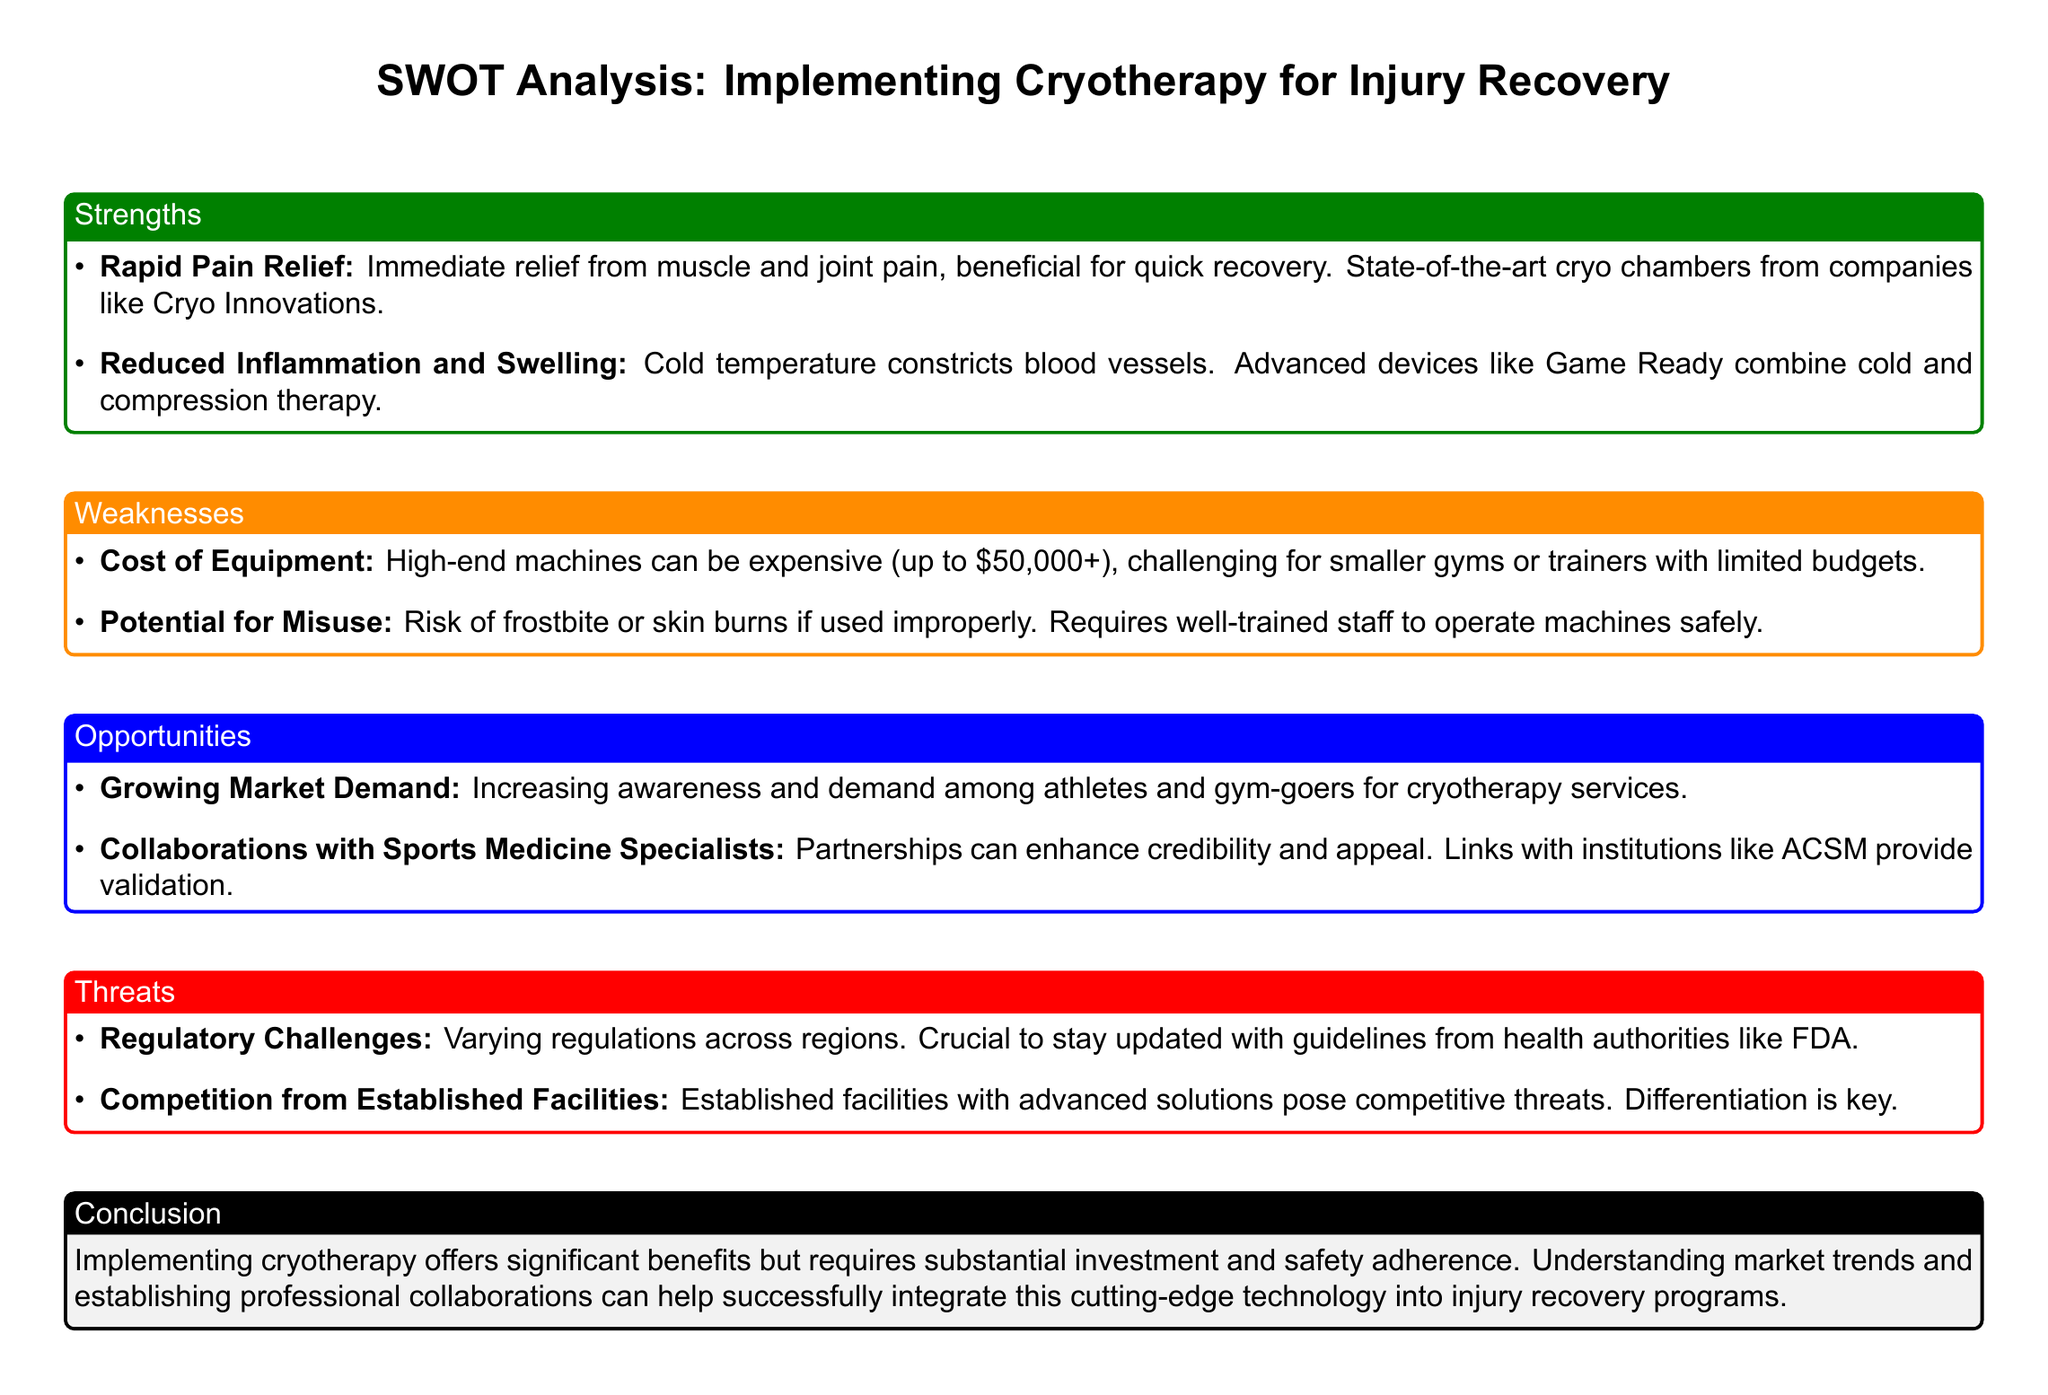What is one strength of implementing cryotherapy? The strength is described in the strengths section, which mentions rapid pain relief as an immediate benefit of cryotherapy.
Answer: Rapid Pain Relief What is the cost of cryotherapy equipment? The document states that high-end machines can cost up to $50,000 or more, which is mentioned in the weaknesses section.
Answer: $50,000+ What is a significant opportunity for cryotherapy services? The growing market demand and increasing awareness among athletes and gym-goers is highlighted as an opportunity in the document.
Answer: Growing Market Demand What is a potential threat to implementing cryotherapy? Regulatory challenges are mentioned as a threat, indicating there are varying regulations across regions.
Answer: Regulatory Challenges Which advanced devices combine cold and compression therapy? The document notes that devices like Game Ready combine cold and compression therapy, representing a cutting-edge approach.
Answer: Game Ready What is the recommended action to ensure safe operation of cryotherapy machines? The document specifies that well-trained staff is required to operate the machines safely, addressing the risk of misuse.
Answer: Well-trained staff With whom can partnerships enhance the credibility of cryotherapy services? Collaborations with sports medicine specialists are mentioned as a way to enhance credibility and appeal.
Answer: Sports Medicine Specialists What do established facilities with advanced solutions pose a threat to? The document highlights that they pose competitive threats to those implementing cryotherapy services.
Answer: Competitive threats What is crucial for staying compliant with cryotherapy regulations? The document states that it is crucial to stay updated with guidelines from health authorities like the FDA.
Answer: Health authorities like FDA 